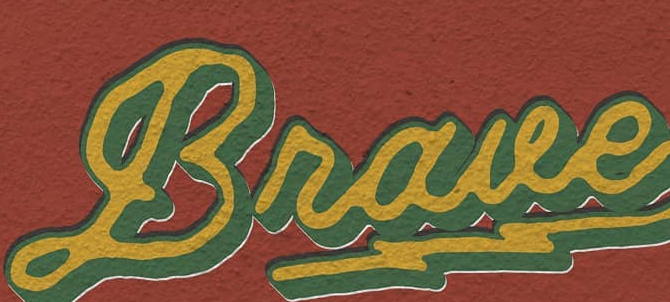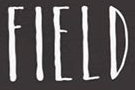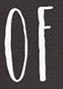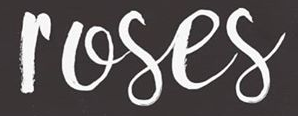Transcribe the words shown in these images in order, separated by a semicolon. Braue; FIELD; OF; roses 